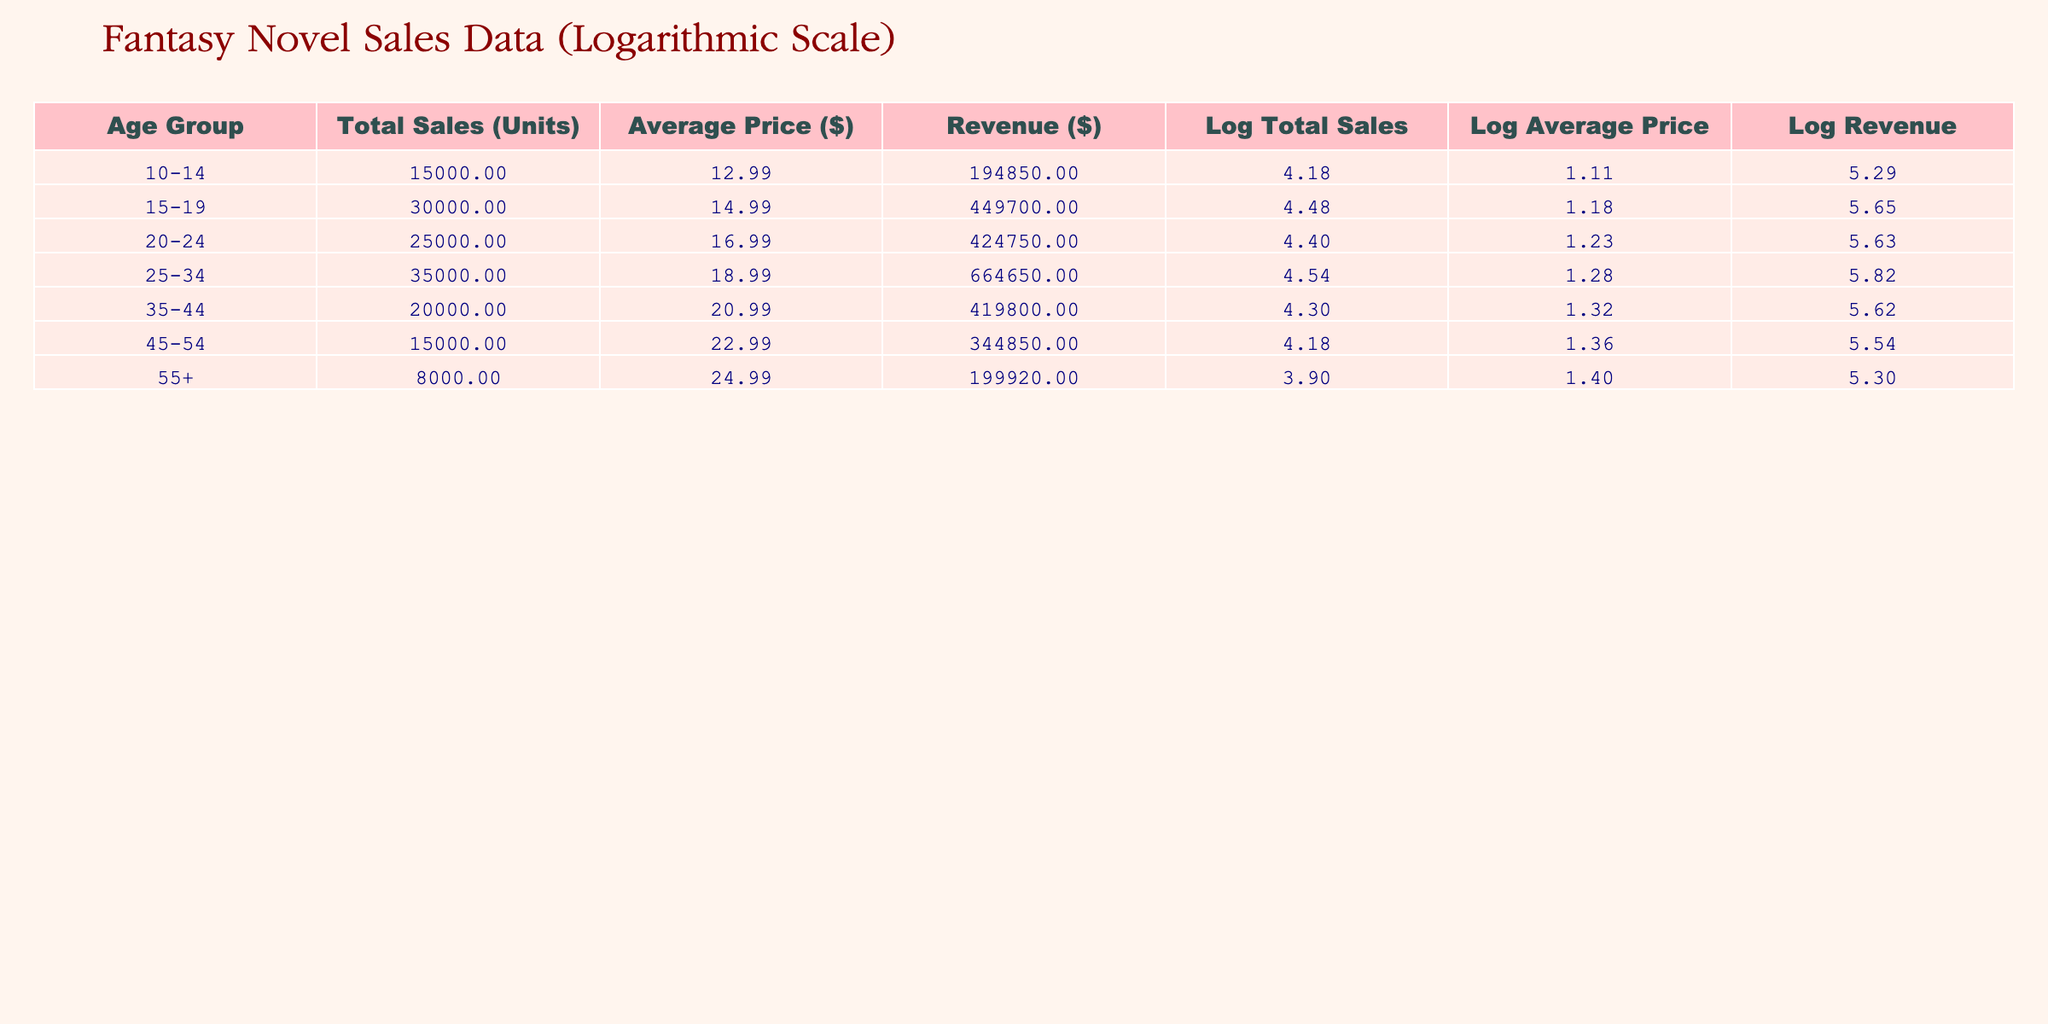What is the total sales for the age group 25-34? The table shows a specific column for total sales corresponding to the age group 25-34. The value in this row under the Total Sales (Units) column is 35000.
Answer: 35000 What is the average price of novels sold to the age group 45-54? The table includes an Average Price ($) column. For the age group 45-54, the corresponding value is 22.99.
Answer: 22.99 Is the revenue from the 15-19 age group higher than that from the 35-44 age group? To compare, we look at the Revenue ($) column. The revenue for the 15-19 age group is 449700, while for the 35-44 age group, it is 419800. Since 449700 is greater than 419800, the answer is yes.
Answer: Yes What is the average revenue across all age groups? First, we sum the revenue from each age group: 194850 + 449700 + 424750 + 664650 + 419800 + 344850 + 199920 = 2399200. There are 7 age groups, so we divide the total revenue by 7, which gives us an average of 342742.86.
Answer: 342742.86 Which age group has the highest revenue, and what is that revenue? We scan through the Revenue ($) column to find the maximum value. The age group 25-34 has a revenue of 664650, which is the highest among all.
Answer: 25-34, 664650 What is the difference in total sales between the 10-14 and 55+ age groups? The Total Sales (Units) for the age group 10-14 is 15000, while for 55+, it is 8000. The difference is calculated as 15000 - 8000 = 7000.
Answer: 7000 Are the total sales for the age group 20-24 less than those for age group 35-44? The total sales for 20-24 is 25000, whereas for 35-44, it is 20000. Since 25000 is greater than 20000, the answer is no.
Answer: No What is the combined average price for the age groups 10-14 and 55+? The average prices for these age groups are 12.99 and 24.99, respectively. We sum them: 12.99 + 24.99 = 37.98 and divide by 2 to find the average: 37.98 / 2 = 18.99.
Answer: 18.99 